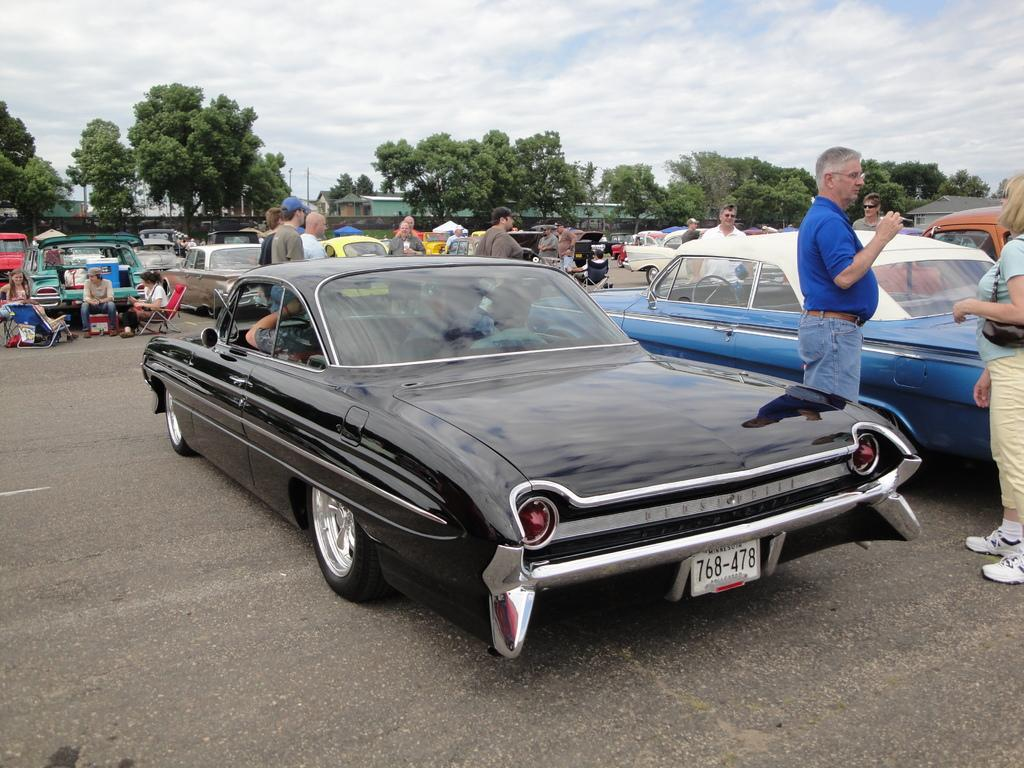What can be seen on the road in the image? There are vehicles parked on the road in the image. What is located near the parked vehicles? Trees are present around the parked vehicles. What are some people doing in the image? Some people are sitting on chairs, while others are standing on the road. What is the color of the sky in the image? The sky is blue in the image. Where are the cows located in the image? There are no cows present in the image. What type of dock can be seen near the standing people in the image? There is no dock present in the image. 